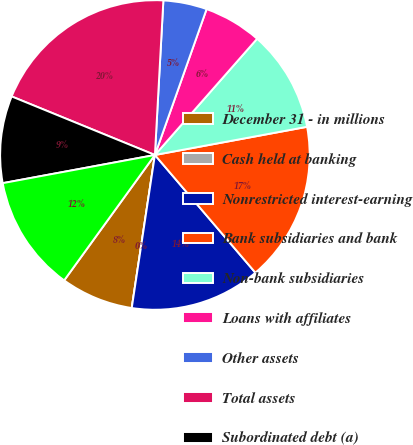Convert chart to OTSL. <chart><loc_0><loc_0><loc_500><loc_500><pie_chart><fcel>December 31 - in millions<fcel>Cash held at banking<fcel>Nonrestricted interest-earning<fcel>Bank subsidiaries and bank<fcel>Non-bank subsidiaries<fcel>Loans with affiliates<fcel>Other assets<fcel>Total assets<fcel>Subordinated debt (a)<fcel>Senior debt (a)<nl><fcel>7.58%<fcel>0.0%<fcel>13.64%<fcel>16.67%<fcel>10.61%<fcel>6.06%<fcel>4.55%<fcel>19.7%<fcel>9.09%<fcel>12.12%<nl></chart> 